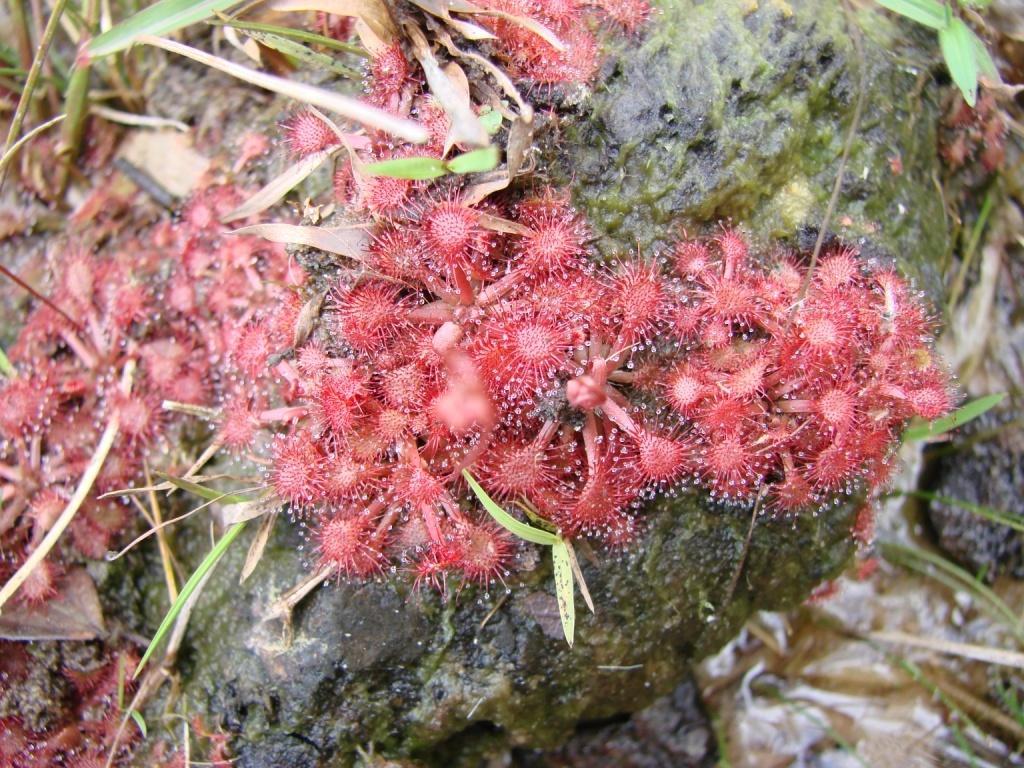Could you give a brief overview of what you see in this image? The picture consists of plants, grass and other species. 